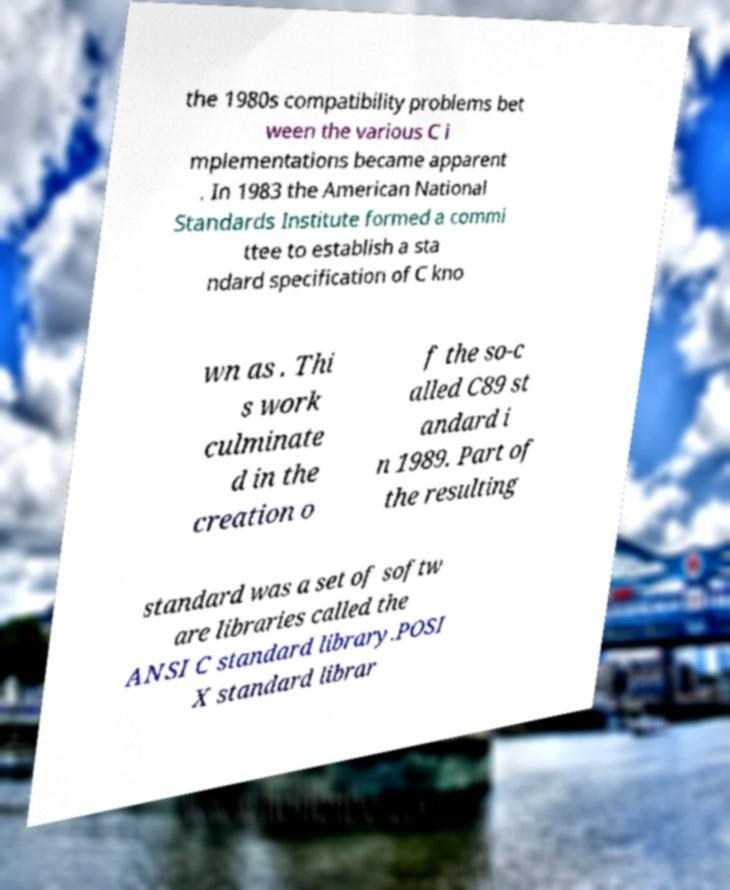Could you extract and type out the text from this image? the 1980s compatibility problems bet ween the various C i mplementations became apparent . In 1983 the American National Standards Institute formed a commi ttee to establish a sta ndard specification of C kno wn as . Thi s work culminate d in the creation o f the so-c alled C89 st andard i n 1989. Part of the resulting standard was a set of softw are libraries called the ANSI C standard library.POSI X standard librar 